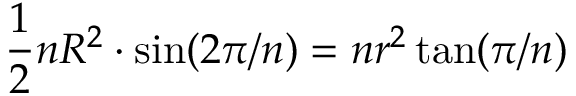Convert formula to latex. <formula><loc_0><loc_0><loc_500><loc_500>{ \frac { 1 } { 2 } } n R ^ { 2 } \cdot \sin ( 2 \pi / n ) = n r ^ { 2 } \tan ( \pi / n ) \,</formula> 